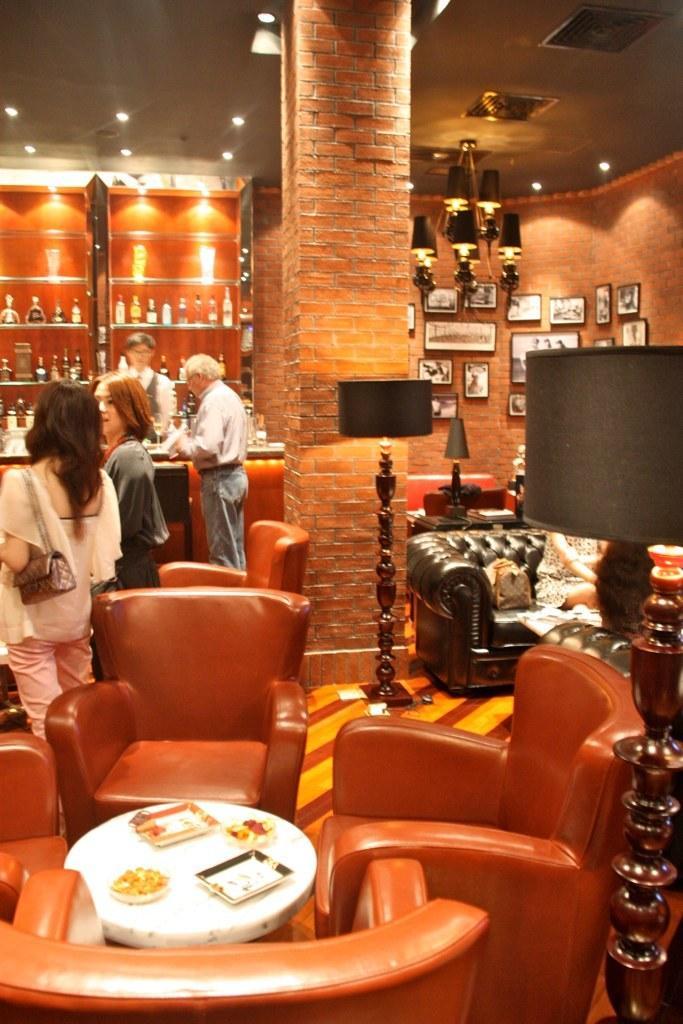Could you give a brief overview of what you see in this image? In the image we see there are people who are standing and there are chairs around a table and there is a table lamp and the pillar and the wall are made up of red bricks. 